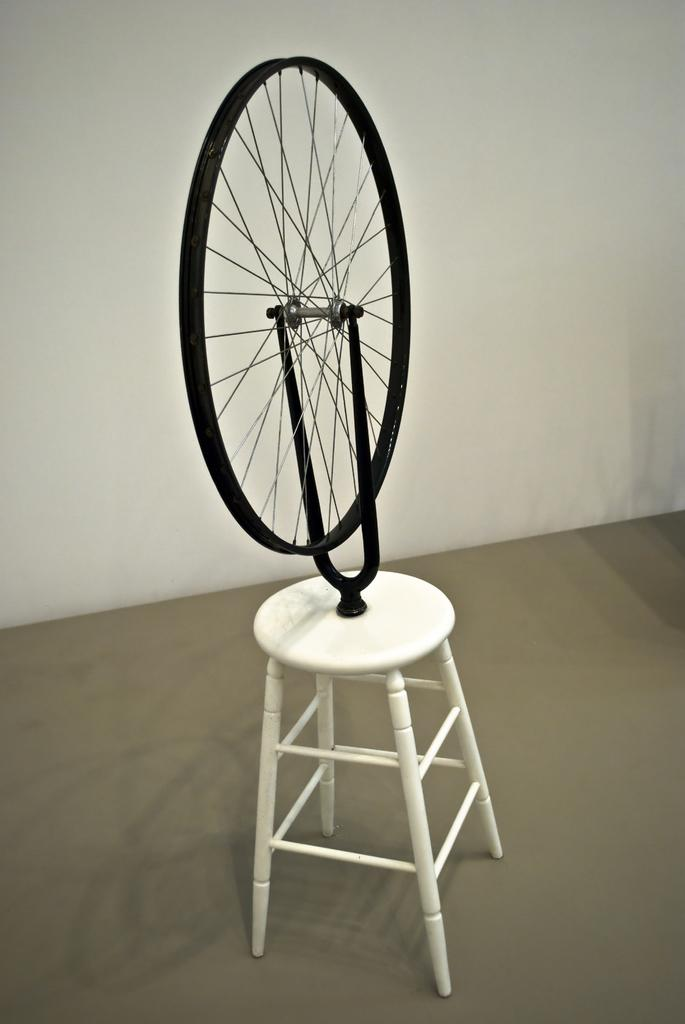What object is the main focus of the image? The main object in the image is a wheel. Where is the wheel placed? The wheel is on a stool. What is behind the stool in the image? The stool is in front of a wall. How many children are playing with the wheel in the image? There are no children present in the image; it only features a wheel on a stool in front of a wall. 